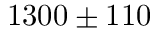<formula> <loc_0><loc_0><loc_500><loc_500>1 3 0 0 \pm 1 1 0</formula> 